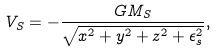<formula> <loc_0><loc_0><loc_500><loc_500>V _ { S } = - \frac { G M _ { S } } { \sqrt { x ^ { 2 } + y ^ { 2 } + z ^ { 2 } + \epsilon _ { s } ^ { 2 } } } ,</formula> 